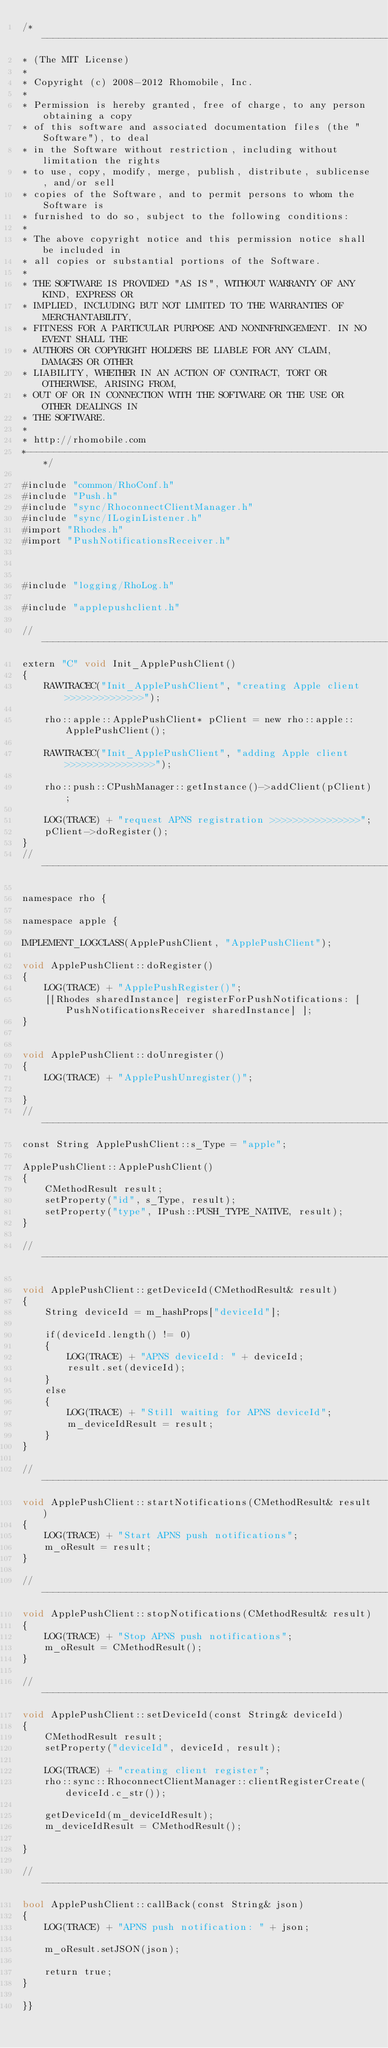Convert code to text. <code><loc_0><loc_0><loc_500><loc_500><_ObjectiveC_>/*------------------------------------------------------------------------
* (The MIT License)
*
* Copyright (c) 2008-2012 Rhomobile, Inc.
*
* Permission is hereby granted, free of charge, to any person obtaining a copy
* of this software and associated documentation files (the "Software"), to deal
* in the Software without restriction, including without limitation the rights
* to use, copy, modify, merge, publish, distribute, sublicense, and/or sell
* copies of the Software, and to permit persons to whom the Software is
* furnished to do so, subject to the following conditions:
*
* The above copyright notice and this permission notice shall be included in
* all copies or substantial portions of the Software.
*
* THE SOFTWARE IS PROVIDED "AS IS", WITHOUT WARRANTY OF ANY KIND, EXPRESS OR
* IMPLIED, INCLUDING BUT NOT LIMITED TO THE WARRANTIES OF MERCHANTABILITY,
* FITNESS FOR A PARTICULAR PURPOSE AND NONINFRINGEMENT. IN NO EVENT SHALL THE
* AUTHORS OR COPYRIGHT HOLDERS BE LIABLE FOR ANY CLAIM, DAMAGES OR OTHER
* LIABILITY, WHETHER IN AN ACTION OF CONTRACT, TORT OR OTHERWISE, ARISING FROM,
* OUT OF OR IN CONNECTION WITH THE SOFTWARE OR THE USE OR OTHER DEALINGS IN
* THE SOFTWARE.
*
* http://rhomobile.com
*------------------------------------------------------------------------*/

#include "common/RhoConf.h"
#include "Push.h"
#include "sync/RhoconnectClientManager.h"
#include "sync/ILoginListener.h"
#import "Rhodes.h"
#import "PushNotificationsReceiver.h"



#include "logging/RhoLog.h"

#include "applepushclient.h"

//----------------------------------------------------------------------------------------------------------------------
extern "C" void Init_ApplePushClient()
{
    RAWTRACEC("Init_ApplePushClient", "creating Apple client >>>>>>>>>>>>>>");

    rho::apple::ApplePushClient* pClient = new rho::apple::ApplePushClient();

    RAWTRACEC("Init_ApplePushClient", "adding Apple client >>>>>>>>>>>>>>>>");

    rho::push::CPushManager::getInstance()->addClient(pClient);
    
    LOG(TRACE) + "request APNS registration >>>>>>>>>>>>>>>>";
    pClient->doRegister();
}
//----------------------------------------------------------------------------------------------------------------------

namespace rho {
    
namespace apple {

IMPLEMENT_LOGCLASS(ApplePushClient, "ApplePushClient");

void ApplePushClient::doRegister()
{
    LOG(TRACE) + "ApplePushRegister()";
    [[Rhodes sharedInstance] registerForPushNotifications: [PushNotificationsReceiver sharedInstance] ];
}


void ApplePushClient::doUnregister()
{
    LOG(TRACE) + "ApplePushUnregister()";

}
//----------------------------------------------------------------------------------------------------------------------
const String ApplePushClient::s_Type = "apple";

ApplePushClient::ApplePushClient()
{
    CMethodResult result;
    setProperty("id", s_Type, result);
    setProperty("type", IPush::PUSH_TYPE_NATIVE, result);
}

//----------------------------------------------------------------------------------------------------------------------

void ApplePushClient::getDeviceId(CMethodResult& result)
{
    String deviceId = m_hashProps["deviceId"];

    if(deviceId.length() != 0)
    {
        LOG(TRACE) + "APNS deviceId: " + deviceId;
        result.set(deviceId);
    }
    else
    {
        LOG(TRACE) + "Still waiting for APNS deviceId";
        m_deviceIdResult = result;
    }
}

//----------------------------------------------------------------------------------------------------------------------
void ApplePushClient::startNotifications(CMethodResult& result)
{
    LOG(TRACE) + "Start APNS push notifications";
    m_oResult = result;
}

//----------------------------------------------------------------------------------------------------------------------
void ApplePushClient::stopNotifications(CMethodResult& result)
{
    LOG(TRACE) + "Stop APNS push notifications";
    m_oResult = CMethodResult();
}

//----------------------------------------------------------------------------------------------------------------------
void ApplePushClient::setDeviceId(const String& deviceId)
{
    CMethodResult result;
    setProperty("deviceId", deviceId, result);

    LOG(TRACE) + "creating client register";
    rho::sync::RhoconnectClientManager::clientRegisterCreate(deviceId.c_str());

    getDeviceId(m_deviceIdResult);
    m_deviceIdResult = CMethodResult();

}

//----------------------------------------------------------------------------------------------------------------------
bool ApplePushClient::callBack(const String& json)
{
    LOG(TRACE) + "APNS push notification: " + json;

    m_oResult.setJSON(json);

    return true;
}

}}

</code> 